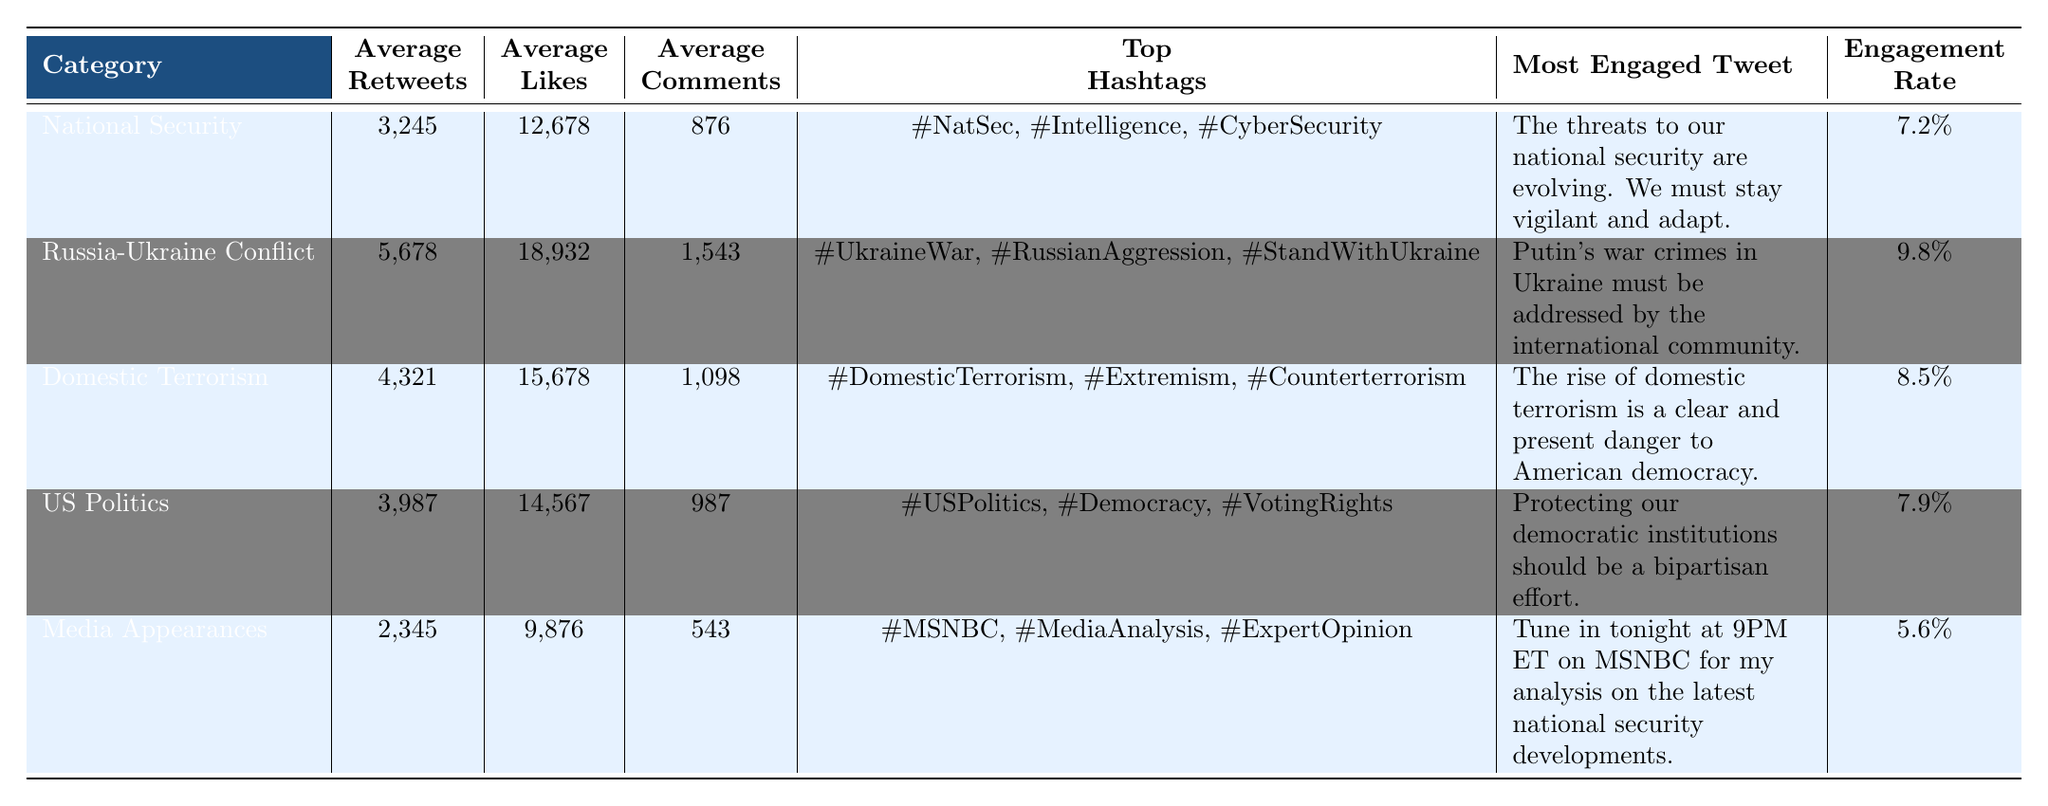What is the average number of retweets for the "Russia-Ukraine Conflict" category? The average retweets for the "Russia-Ukraine Conflict" category is explicitly listed as 5,678 in the table.
Answer: 5678 Which topic category has the highest engagement rate? By examining the engagement rates, "Russia-Ukraine Conflict" has the highest engagement rate of 9.8%, compared to the other categories listed.
Answer: Russia-Ukraine Conflict What is the total number of average likes across all topic categories? To find the total average likes, I sum the average likes from each category: 12,678 + 18,932 + 15,678 + 14,567 + 9,876 = 71,731.
Answer: 71731 True or False: The "Media Appearances" category has more comments than the "National Security" category. The average comments for "Media Appearances" is 543, while for "National Security" it is 876. Thus, "Media Appearances" has fewer comments.
Answer: False What is the difference in average likes between "Domestic Terrorism" and "US Politics"? The average likes for "Domestic Terrorism" is 15,678 and for "US Politics" it is 14,567. Calculating the difference: 15,678 - 14,567 = 1,111.
Answer: 1111 Which topic has the least average retweets, and what is that value? The topic category with the least average retweets is "Media Appearances" with 2,345 retweets, the lowest among the listed categories.
Answer: 2345 Identify the tweet from "US Politics" with the highest engagement. The most engaged tweet under "US Politics" is stated as "Protecting our democratic institutions should be a bipartisan effort."
Answer: Protecting our democratic institutions should be a bipartisan effort How many times more average likes does "Russia-Ukraine Conflict" have compared to "Media Appearances"? The average likes for "Russia-Ukraine Conflict" is 18,932 and for "Media Appearances" it is 9,876. To find the ratio: 18,932 / 9,876 = approximately 1.91.
Answer: 1.91 What are the top three hashtags used in the "Domestic Terrorism" category? The top hashtags listed for "Domestic Terrorism" are: #DomesticTerrorism, #Extremism, and #Counterterrorism.
Answer: #DomesticTerrorism, #Extremism, #Counterterrorism If we consider only the engagement rates, which two categories stand out as the most engaging? The two categories with the highest engagement rates are "Russia-Ukraine Conflict" at 9.8% and "Domestic Terrorism" at 8.5%, indicating high engagement relative to their content.
Answer: Russia-Ukraine Conflict and Domestic Terrorism 